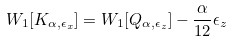<formula> <loc_0><loc_0><loc_500><loc_500>W _ { 1 } [ K _ { \alpha , \epsilon _ { x } } ] = W _ { 1 } [ Q _ { \alpha , \epsilon _ { z } } ] - \frac { \alpha } { 1 2 } \epsilon _ { z }</formula> 